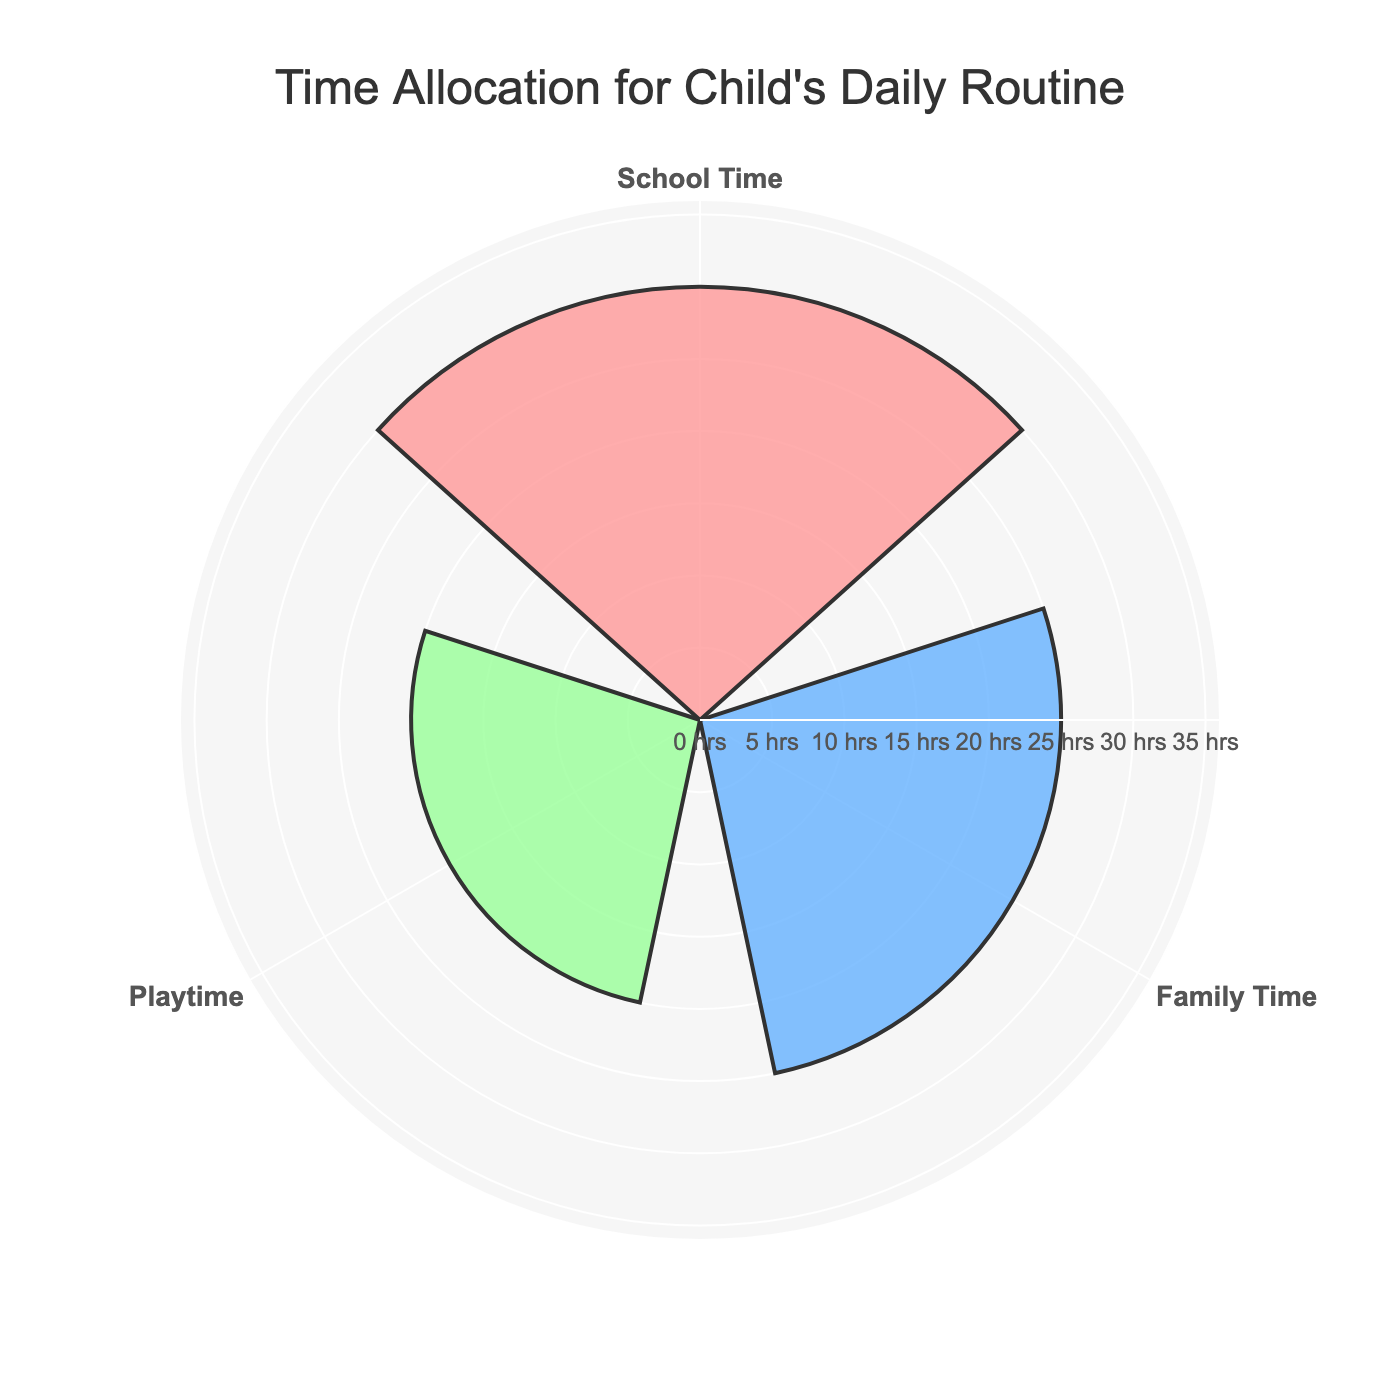What are the three categories shown in the rose chart? The rose chart shows the three categories with the highest hours per week values. From the given data, these are 'School Time,' 'Playtime,' and 'Family Time.'
Answer: School Time, Playtime, Family Time What is the title of the rose chart? The title of the chart, typically found at the top, describes the data being visualized. In this case, the title is "Time Allocation for Child's Daily Routine."
Answer: Time Allocation for Child's Daily Routine Which category has the highest number of hours per week? Examine the radial axis lengths of the bars in the chart. The longest bar represents the highest number of hours per week.
Answer: School Time How many hours per week are allocated to Playtime? Check the radial length of the segment labeled 'Playtime' on the chart. The radial axis value for Playtime is 20 hours per week.
Answer: 20 What is the combined total of hours per week for School Time and Family Time? Identify the hours for 'School Time' (30 hours) and 'Family Time' (25 hours) on the chart. Add these values together to find the combined total, which is 30 + 25.
Answer: 55 How does Family Time compare to Playtime in terms of hours per week? Compare the radial lengths of Family Time and Playtime segments. Family Time has 25 hours and Playtime has 20 hours, so Family Time has more hours.
Answer: Family Time has more hours than Playtime Which category occupies the smallest portion of the rose chart? Look for the category with the shortest radial length in the top three categories. Playtime, with 20 hours per week, has the shortest radial length here.
Answer: Playtime If the total time for the three shown categories is spent in a week, what is the average time per category? Add the hours of the three categories shown: 30 (School Time) + 25 (Family Time) + 20 (Playtime) = 75 hours total. Divide by the number of categories (3). The average is 75/3 hours.
Answer: 25 What color represents Family Time in the chart? Family Time's segment on the chart is colored with the third marker in the sequence, identified as a greenish shade.
Answer: Green 